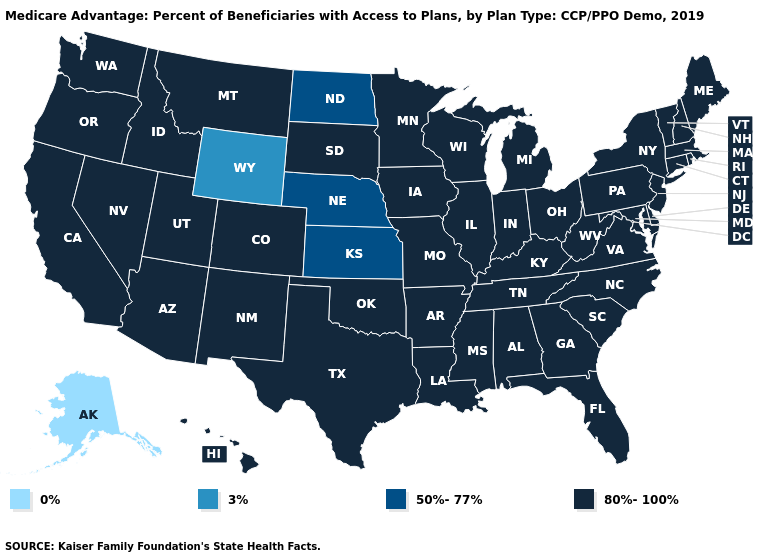Does Hawaii have the lowest value in the USA?
Write a very short answer. No. Name the states that have a value in the range 80%-100%?
Concise answer only. Alabama, Arizona, Arkansas, California, Colorado, Connecticut, Delaware, Florida, Georgia, Hawaii, Idaho, Illinois, Indiana, Iowa, Kentucky, Louisiana, Maine, Maryland, Massachusetts, Michigan, Minnesota, Mississippi, Missouri, Montana, Nevada, New Hampshire, New Jersey, New Mexico, New York, North Carolina, Ohio, Oklahoma, Oregon, Pennsylvania, Rhode Island, South Carolina, South Dakota, Tennessee, Texas, Utah, Vermont, Virginia, Washington, West Virginia, Wisconsin. Is the legend a continuous bar?
Concise answer only. No. How many symbols are there in the legend?
Concise answer only. 4. What is the value of Hawaii?
Be succinct. 80%-100%. Does Texas have the same value as Oregon?
Keep it brief. Yes. Does Mississippi have the same value as Washington?
Quick response, please. Yes. What is the value of Wyoming?
Give a very brief answer. 3%. What is the value of West Virginia?
Keep it brief. 80%-100%. What is the highest value in the MidWest ?
Answer briefly. 80%-100%. Does Oregon have a lower value than Wisconsin?
Keep it brief. No. What is the value of Arizona?
Quick response, please. 80%-100%. What is the value of Missouri?
Answer briefly. 80%-100%. Name the states that have a value in the range 50%-77%?
Be succinct. Kansas, Nebraska, North Dakota. 